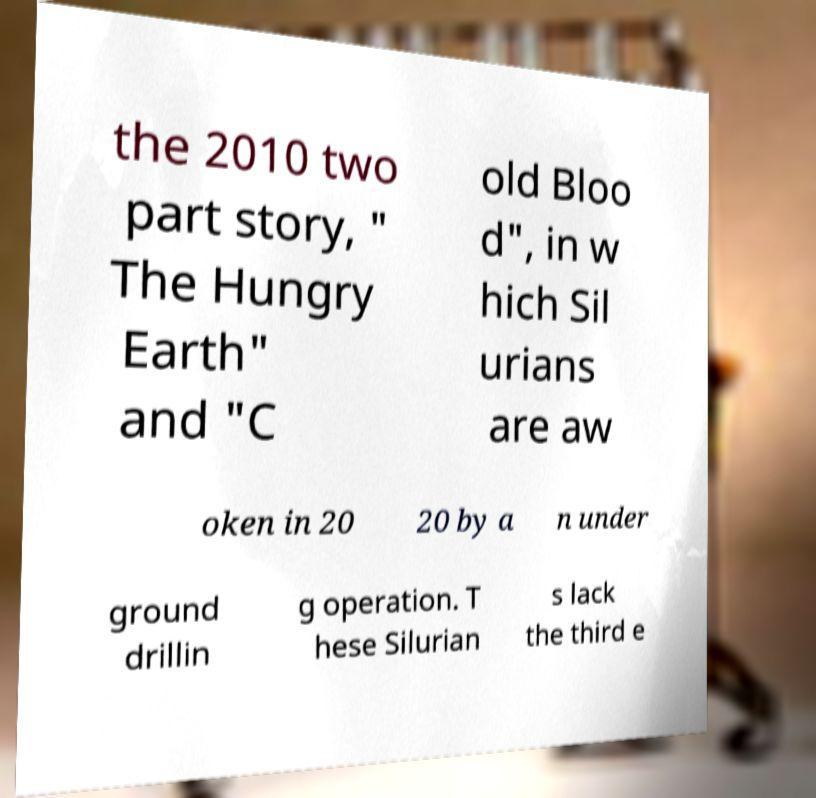Can you read and provide the text displayed in the image?This photo seems to have some interesting text. Can you extract and type it out for me? the 2010 two part story, " The Hungry Earth" and "C old Bloo d", in w hich Sil urians are aw oken in 20 20 by a n under ground drillin g operation. T hese Silurian s lack the third e 